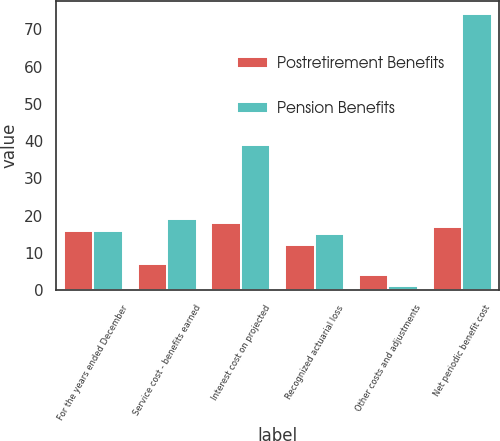Convert chart. <chart><loc_0><loc_0><loc_500><loc_500><stacked_bar_chart><ecel><fcel>For the years ended December<fcel>Service cost - benefits earned<fcel>Interest cost on projected<fcel>Recognized actuarial loss<fcel>Other costs and adjustments<fcel>Net periodic benefit cost<nl><fcel>Postretirement Benefits<fcel>16<fcel>7<fcel>18<fcel>12<fcel>4<fcel>17<nl><fcel>Pension Benefits<fcel>16<fcel>19<fcel>39<fcel>15<fcel>1<fcel>74<nl></chart> 